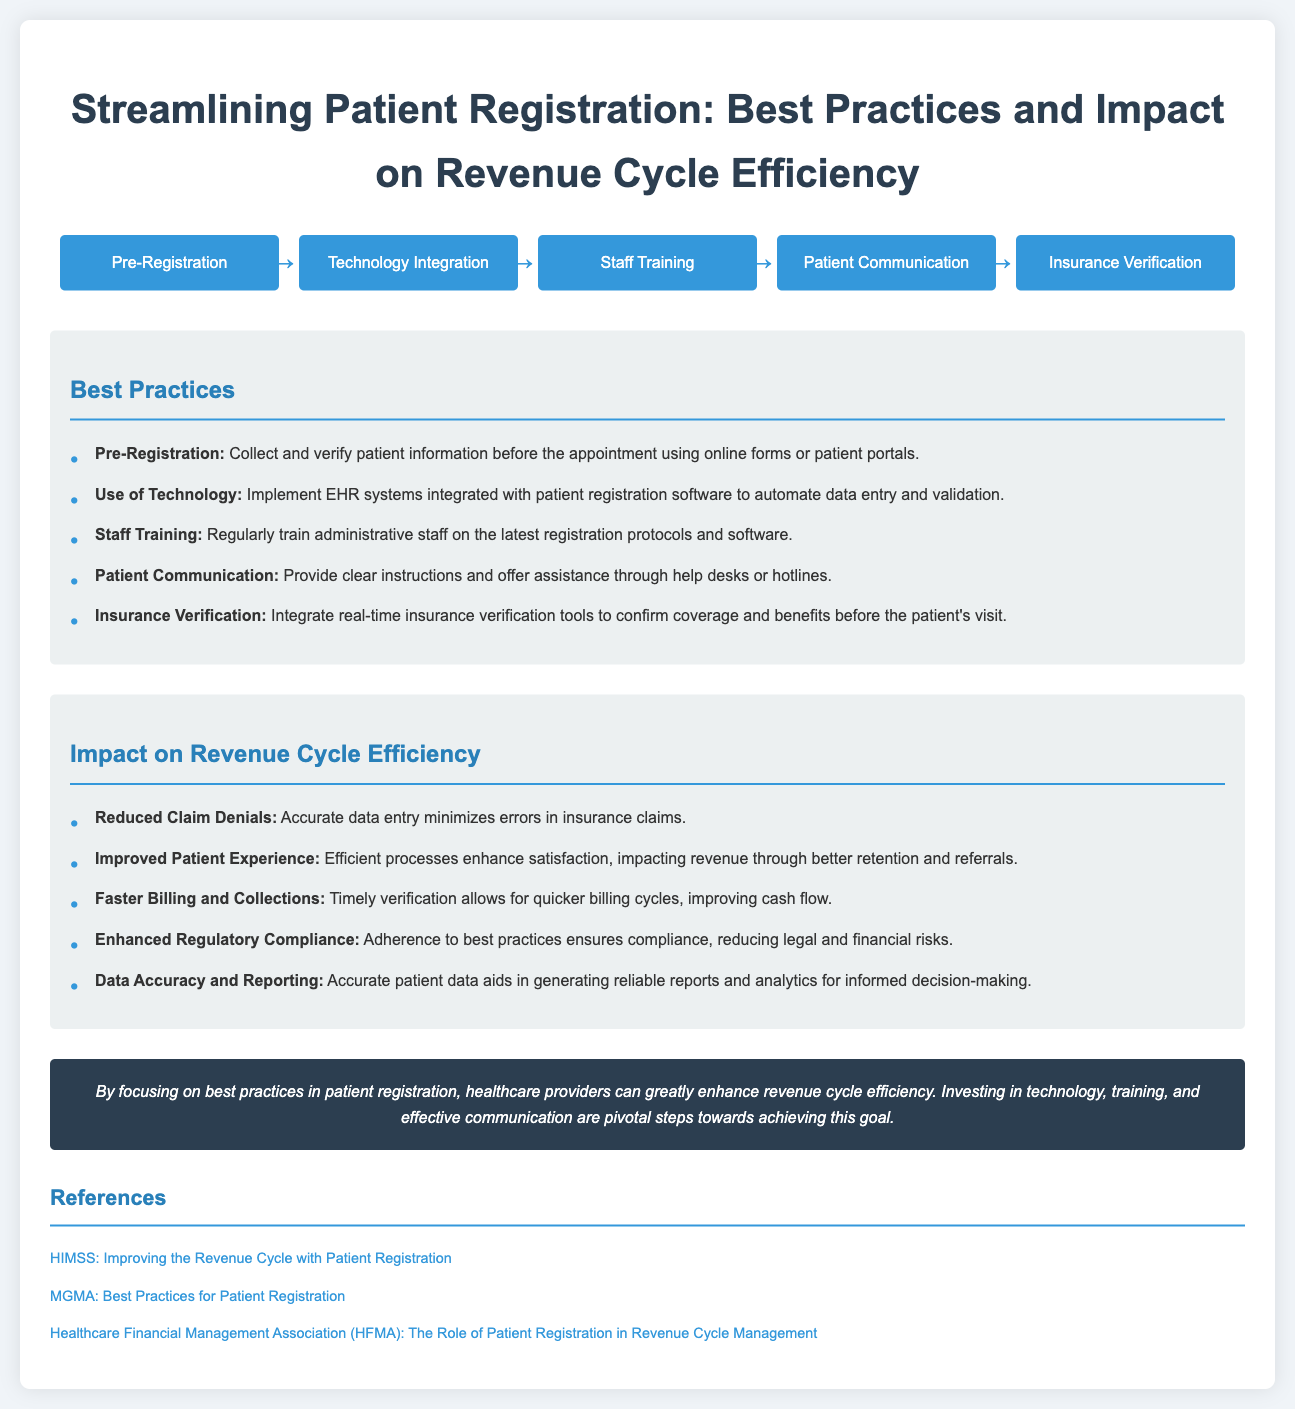what is the first step in the patient registration process? The first step mentioned in the process flow is "Pre-Registration."
Answer: Pre-Registration what is one best practice for patient communication? The best practice states to provide clear instructions and offer assistance through help desks or hotlines.
Answer: Provide clear instructions what impact does accurate data entry have on claim denials? The document states that accurate data entry minimizes errors in insurance claims, leading to reduced claim denials.
Answer: Reduced Claim Denials how many steps are there in the process flow for patient registration? The process flow includes five steps, as represented in the infographic.
Answer: Five what is the main conclusion regarding best practices in patient registration? The conclusion emphasizes that focusing on best practices enhances revenue cycle efficiency through various investments.
Answer: Enhance revenue cycle efficiency which aspect is emphasized for staff training in best practices? The document highlights the need for regularly training administrative staff on the latest registration protocols and software.
Answer: Latest registration protocols what tool is suggested for insurance verification? The document recommends integrating real-time insurance verification tools to confirm coverage and benefits.
Answer: Real-time insurance verification tools which organization is referenced for improving revenue cycle management? The HIMSS organization is mentioned as a reference for improving the revenue cycle with patient registration.
Answer: HIMSS 